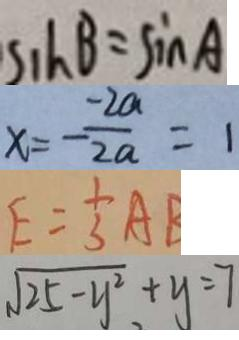<formula> <loc_0><loc_0><loc_500><loc_500>S _ { 1 } h B = \sin A 
 x = - \frac { - 2 a } { 2 a } = 1 
 E = \frac { 1 } { 3 } A B 
 \sqrt { 2 5 - y ^ { 2 } } + y = 7</formula> 